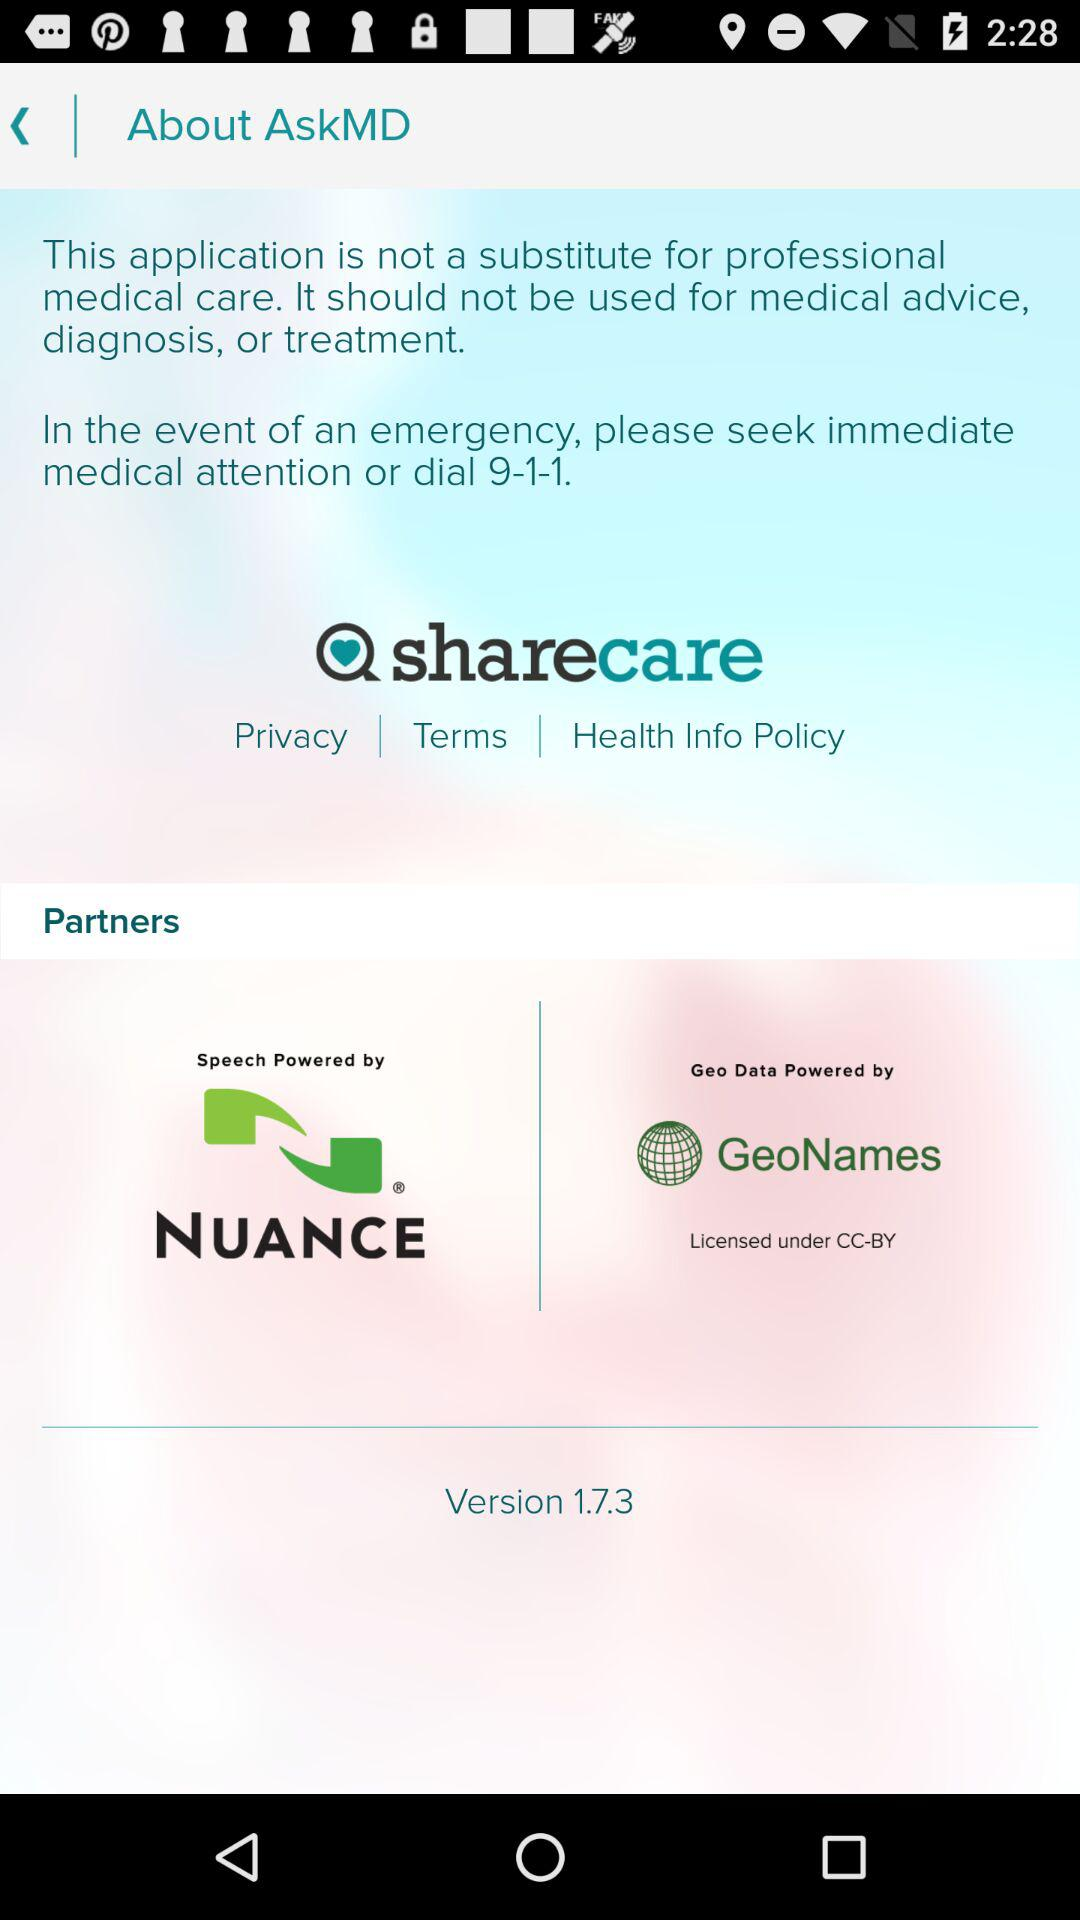What is the name of the application? The name of the application is "sharecare". 